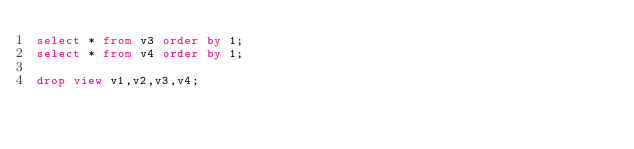Convert code to text. <code><loc_0><loc_0><loc_500><loc_500><_SQL_>select * from v3 order by 1;
select * from v4 order by 1;

drop view v1,v2,v3,v4;





</code> 